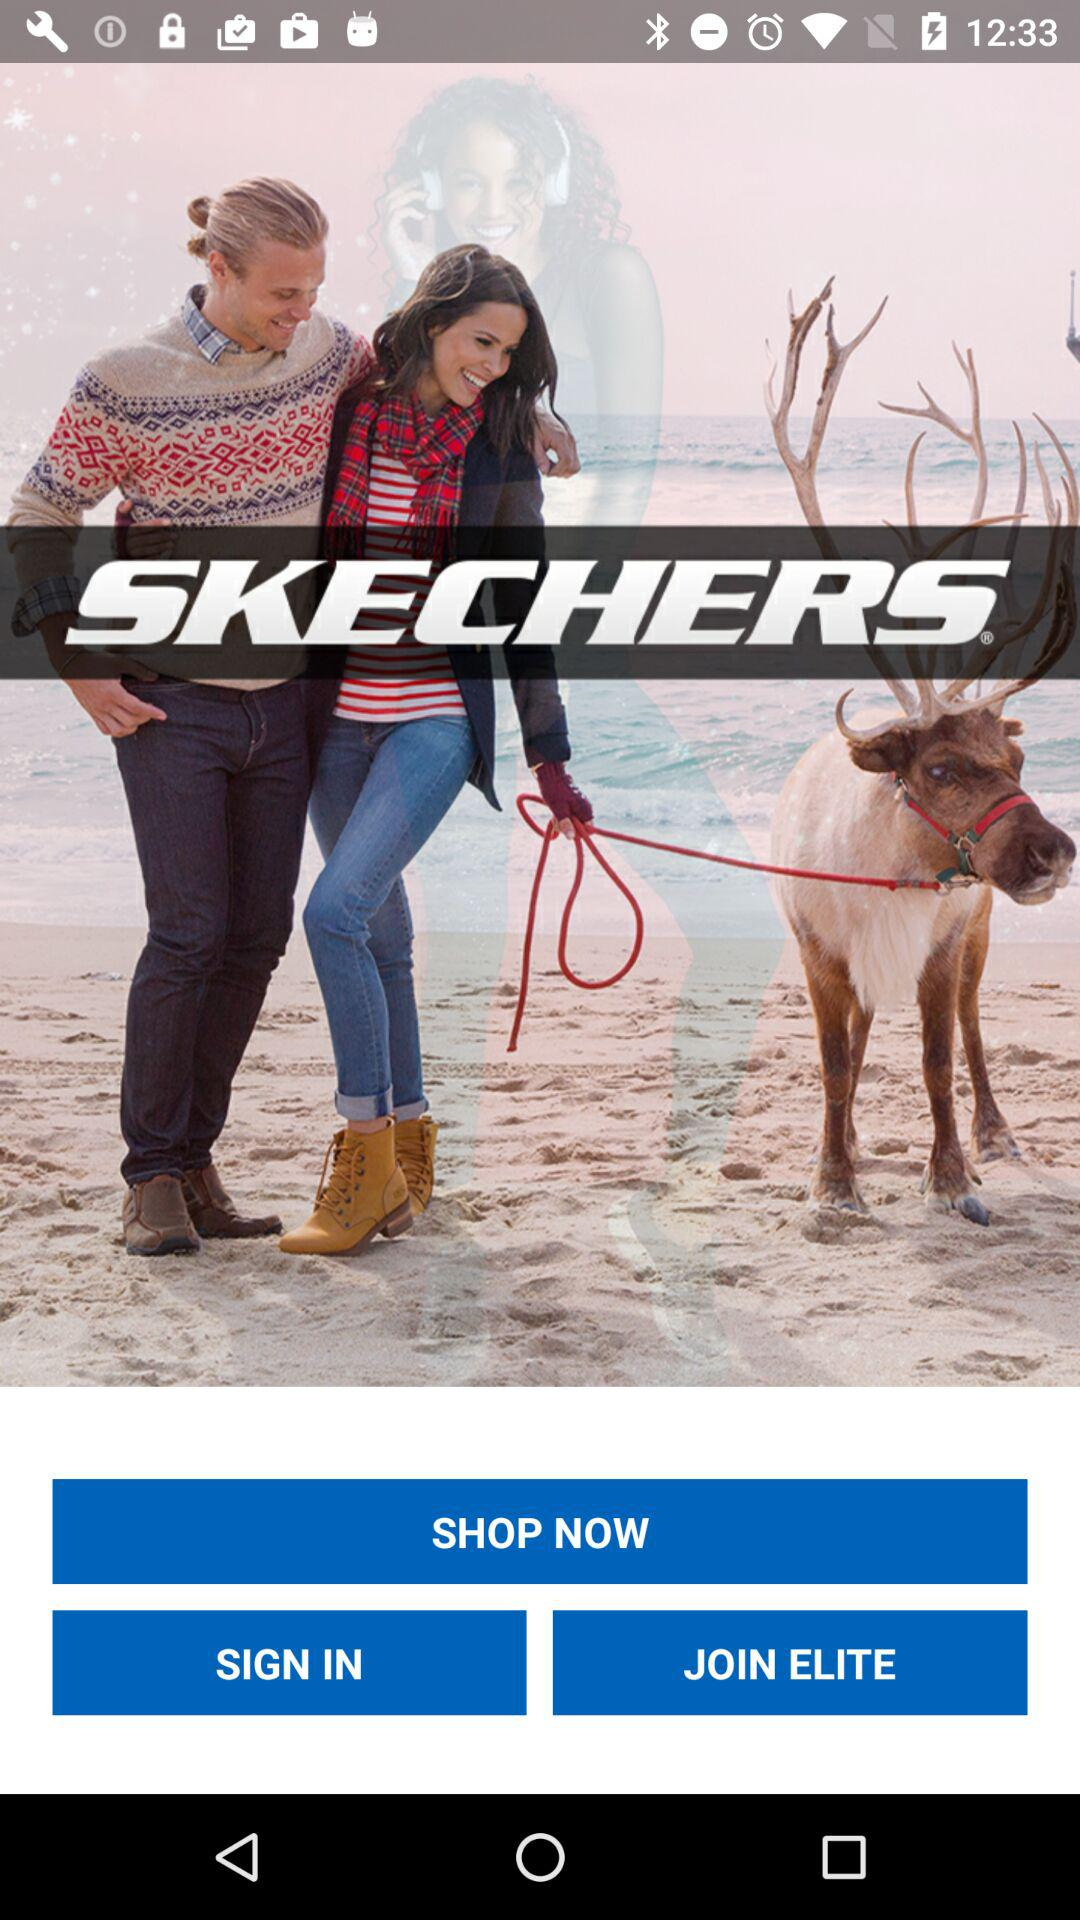What is the application name? The application name is "SKECHERS". 